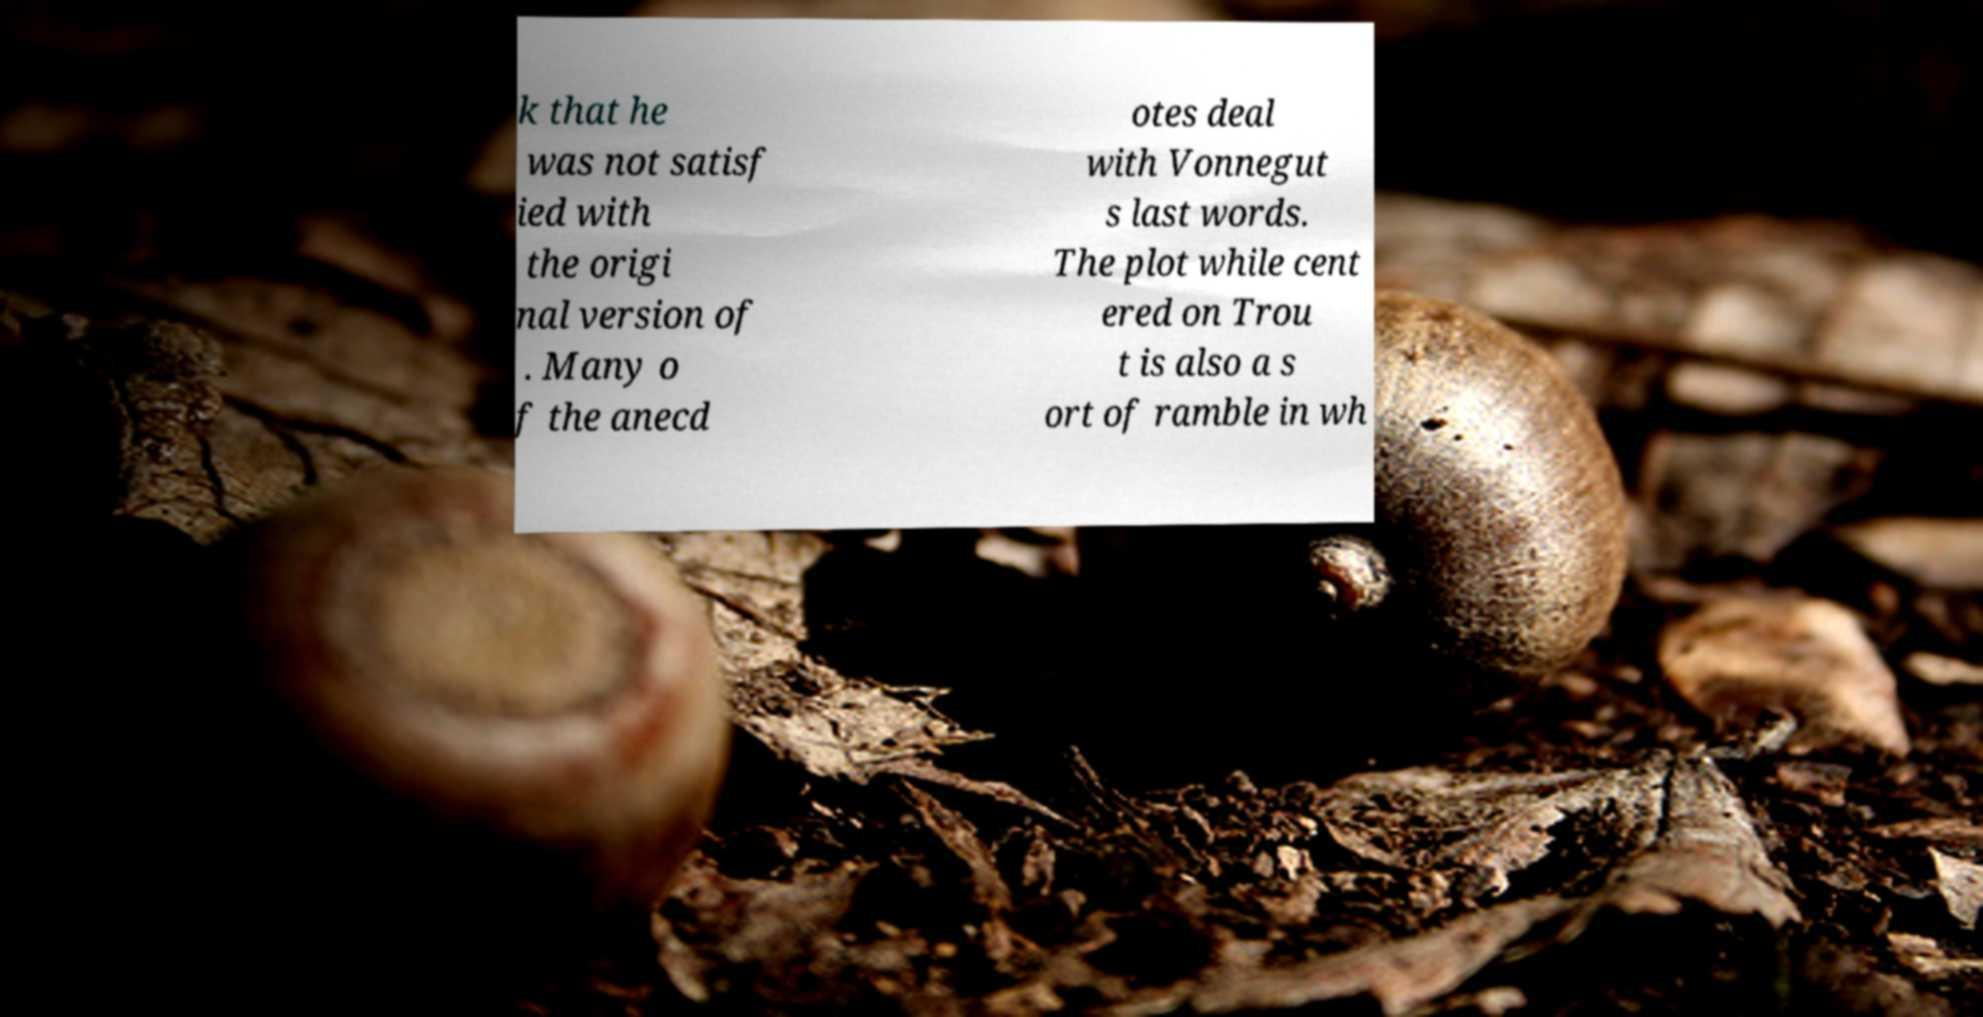Could you assist in decoding the text presented in this image and type it out clearly? k that he was not satisf ied with the origi nal version of . Many o f the anecd otes deal with Vonnegut s last words. The plot while cent ered on Trou t is also a s ort of ramble in wh 